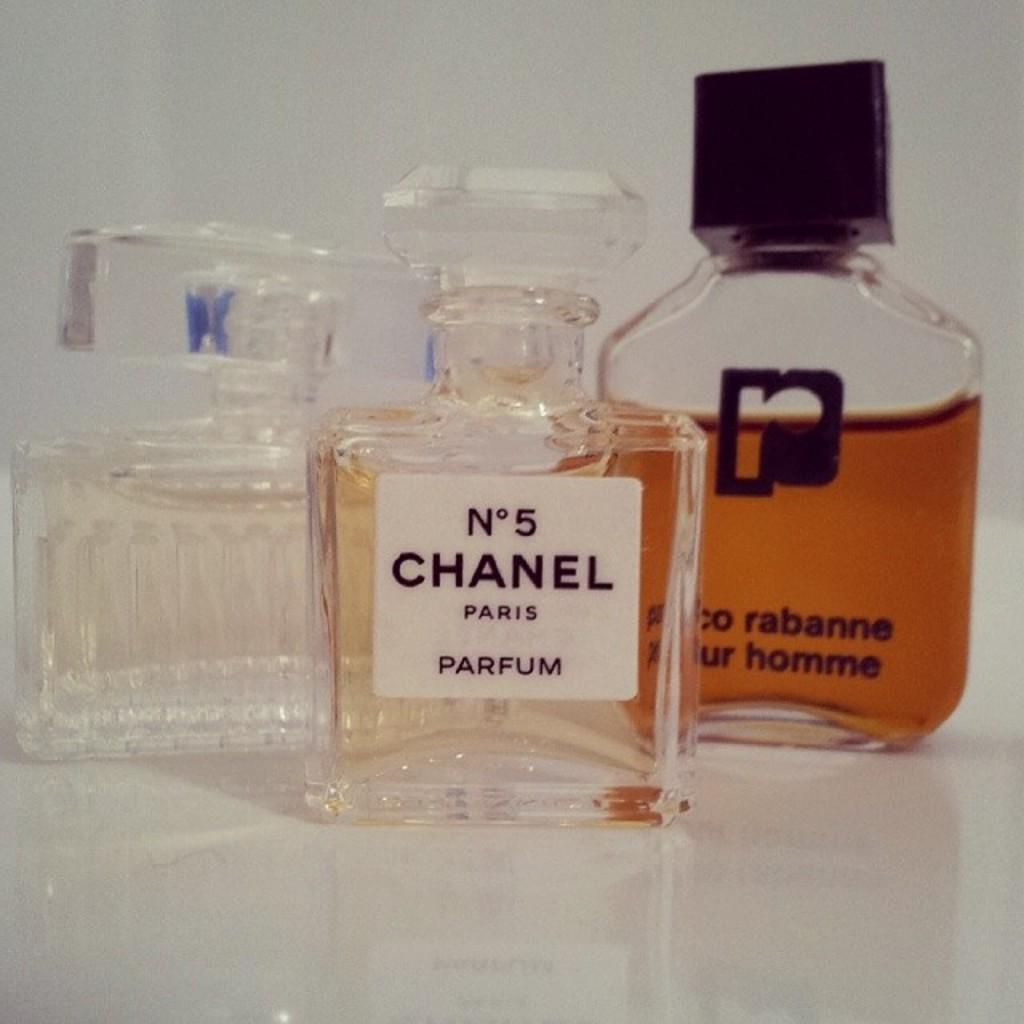<image>
Offer a succinct explanation of the picture presented. A bottle of Chanel perfume is near two other bottles of perfume. 